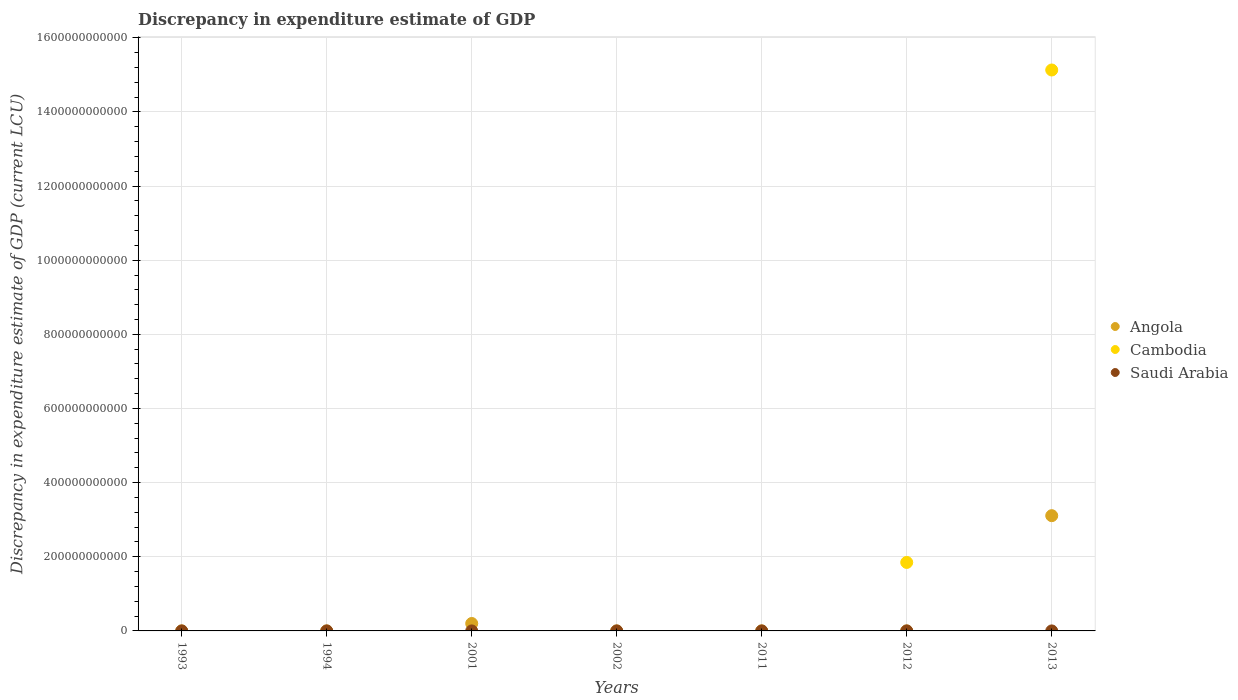What is the discrepancy in expenditure estimate of GDP in Saudi Arabia in 2012?
Provide a succinct answer. 0. Across all years, what is the maximum discrepancy in expenditure estimate of GDP in Angola?
Your answer should be compact. 3.11e+11. What is the total discrepancy in expenditure estimate of GDP in Angola in the graph?
Make the answer very short. 3.31e+11. What is the difference between the discrepancy in expenditure estimate of GDP in Saudi Arabia in 1994 and that in 2013?
Provide a short and direct response. 1.00e+06. What is the difference between the discrepancy in expenditure estimate of GDP in Angola in 2011 and the discrepancy in expenditure estimate of GDP in Saudi Arabia in 2001?
Keep it short and to the point. -1.00e+06. What is the average discrepancy in expenditure estimate of GDP in Cambodia per year?
Your answer should be very brief. 2.43e+11. In the year 2013, what is the difference between the discrepancy in expenditure estimate of GDP in Cambodia and discrepancy in expenditure estimate of GDP in Saudi Arabia?
Your answer should be compact. 1.51e+12. What is the ratio of the discrepancy in expenditure estimate of GDP in Angola in 2002 to that in 2011?
Your response must be concise. 4.00e+08. What is the difference between the highest and the second highest discrepancy in expenditure estimate of GDP in Angola?
Offer a very short reply. 2.91e+11. What is the difference between the highest and the lowest discrepancy in expenditure estimate of GDP in Cambodia?
Your answer should be compact. 1.51e+12. Is the sum of the discrepancy in expenditure estimate of GDP in Angola in 1993 and 1994 greater than the maximum discrepancy in expenditure estimate of GDP in Cambodia across all years?
Your answer should be compact. No. Does the discrepancy in expenditure estimate of GDP in Saudi Arabia monotonically increase over the years?
Ensure brevity in your answer.  No. How many dotlines are there?
Provide a short and direct response. 3. How many years are there in the graph?
Your answer should be very brief. 7. What is the difference between two consecutive major ticks on the Y-axis?
Offer a very short reply. 2.00e+11. Are the values on the major ticks of Y-axis written in scientific E-notation?
Your response must be concise. No. Does the graph contain any zero values?
Offer a terse response. Yes. What is the title of the graph?
Ensure brevity in your answer.  Discrepancy in expenditure estimate of GDP. Does "Jamaica" appear as one of the legend labels in the graph?
Provide a succinct answer. No. What is the label or title of the Y-axis?
Provide a succinct answer. Discrepancy in expenditure estimate of GDP (current LCU). What is the Discrepancy in expenditure estimate of GDP (current LCU) of Angola in 1993?
Offer a terse response. 4100. What is the Discrepancy in expenditure estimate of GDP (current LCU) in Angola in 1994?
Make the answer very short. 4.03e+04. What is the Discrepancy in expenditure estimate of GDP (current LCU) in Saudi Arabia in 1994?
Keep it short and to the point. 1.00e+06. What is the Discrepancy in expenditure estimate of GDP (current LCU) of Angola in 2001?
Provide a short and direct response. 2.00e+1. What is the Discrepancy in expenditure estimate of GDP (current LCU) in Saudi Arabia in 2001?
Provide a succinct answer. 1.00e+06. What is the Discrepancy in expenditure estimate of GDP (current LCU) in Cambodia in 2002?
Ensure brevity in your answer.  0. What is the Discrepancy in expenditure estimate of GDP (current LCU) of Angola in 2011?
Offer a very short reply. 0. What is the Discrepancy in expenditure estimate of GDP (current LCU) in Cambodia in 2011?
Your answer should be very brief. 0. What is the Discrepancy in expenditure estimate of GDP (current LCU) in Angola in 2012?
Offer a terse response. 0. What is the Discrepancy in expenditure estimate of GDP (current LCU) of Cambodia in 2012?
Your answer should be compact. 1.85e+11. What is the Discrepancy in expenditure estimate of GDP (current LCU) in Angola in 2013?
Give a very brief answer. 3.11e+11. What is the Discrepancy in expenditure estimate of GDP (current LCU) in Cambodia in 2013?
Provide a succinct answer. 1.51e+12. What is the Discrepancy in expenditure estimate of GDP (current LCU) in Saudi Arabia in 2013?
Offer a very short reply. 0. Across all years, what is the maximum Discrepancy in expenditure estimate of GDP (current LCU) of Angola?
Provide a succinct answer. 3.11e+11. Across all years, what is the maximum Discrepancy in expenditure estimate of GDP (current LCU) of Cambodia?
Give a very brief answer. 1.51e+12. Across all years, what is the maximum Discrepancy in expenditure estimate of GDP (current LCU) in Saudi Arabia?
Your response must be concise. 1.00e+06. What is the total Discrepancy in expenditure estimate of GDP (current LCU) of Angola in the graph?
Offer a terse response. 3.31e+11. What is the total Discrepancy in expenditure estimate of GDP (current LCU) in Cambodia in the graph?
Your response must be concise. 1.70e+12. What is the total Discrepancy in expenditure estimate of GDP (current LCU) of Saudi Arabia in the graph?
Provide a short and direct response. 2.00e+06. What is the difference between the Discrepancy in expenditure estimate of GDP (current LCU) of Angola in 1993 and that in 1994?
Your answer should be compact. -3.62e+04. What is the difference between the Discrepancy in expenditure estimate of GDP (current LCU) in Angola in 1993 and that in 2001?
Provide a succinct answer. -2.00e+1. What is the difference between the Discrepancy in expenditure estimate of GDP (current LCU) in Angola in 1993 and that in 2002?
Provide a short and direct response. -9.96e+05. What is the difference between the Discrepancy in expenditure estimate of GDP (current LCU) in Angola in 1993 and that in 2011?
Your answer should be compact. 4100. What is the difference between the Discrepancy in expenditure estimate of GDP (current LCU) of Angola in 1993 and that in 2013?
Offer a very short reply. -3.11e+11. What is the difference between the Discrepancy in expenditure estimate of GDP (current LCU) of Angola in 1994 and that in 2001?
Offer a terse response. -2.00e+1. What is the difference between the Discrepancy in expenditure estimate of GDP (current LCU) in Angola in 1994 and that in 2002?
Offer a very short reply. -9.60e+05. What is the difference between the Discrepancy in expenditure estimate of GDP (current LCU) in Angola in 1994 and that in 2011?
Your answer should be very brief. 4.03e+04. What is the difference between the Discrepancy in expenditure estimate of GDP (current LCU) in Angola in 1994 and that in 2013?
Make the answer very short. -3.11e+11. What is the difference between the Discrepancy in expenditure estimate of GDP (current LCU) in Saudi Arabia in 1994 and that in 2013?
Your answer should be very brief. 1.00e+06. What is the difference between the Discrepancy in expenditure estimate of GDP (current LCU) of Angola in 2001 and that in 2002?
Ensure brevity in your answer.  2.00e+1. What is the difference between the Discrepancy in expenditure estimate of GDP (current LCU) in Angola in 2001 and that in 2011?
Provide a succinct answer. 2.00e+1. What is the difference between the Discrepancy in expenditure estimate of GDP (current LCU) in Angola in 2001 and that in 2013?
Offer a terse response. -2.91e+11. What is the difference between the Discrepancy in expenditure estimate of GDP (current LCU) in Saudi Arabia in 2001 and that in 2013?
Give a very brief answer. 1.00e+06. What is the difference between the Discrepancy in expenditure estimate of GDP (current LCU) of Angola in 2002 and that in 2011?
Your answer should be compact. 1.00e+06. What is the difference between the Discrepancy in expenditure estimate of GDP (current LCU) in Angola in 2002 and that in 2013?
Your answer should be very brief. -3.11e+11. What is the difference between the Discrepancy in expenditure estimate of GDP (current LCU) in Angola in 2011 and that in 2013?
Your answer should be compact. -3.11e+11. What is the difference between the Discrepancy in expenditure estimate of GDP (current LCU) of Cambodia in 2012 and that in 2013?
Your response must be concise. -1.33e+12. What is the difference between the Discrepancy in expenditure estimate of GDP (current LCU) in Angola in 1993 and the Discrepancy in expenditure estimate of GDP (current LCU) in Saudi Arabia in 1994?
Your response must be concise. -9.96e+05. What is the difference between the Discrepancy in expenditure estimate of GDP (current LCU) in Angola in 1993 and the Discrepancy in expenditure estimate of GDP (current LCU) in Saudi Arabia in 2001?
Offer a very short reply. -9.96e+05. What is the difference between the Discrepancy in expenditure estimate of GDP (current LCU) in Angola in 1993 and the Discrepancy in expenditure estimate of GDP (current LCU) in Cambodia in 2012?
Provide a succinct answer. -1.85e+11. What is the difference between the Discrepancy in expenditure estimate of GDP (current LCU) of Angola in 1993 and the Discrepancy in expenditure estimate of GDP (current LCU) of Cambodia in 2013?
Your answer should be very brief. -1.51e+12. What is the difference between the Discrepancy in expenditure estimate of GDP (current LCU) of Angola in 1993 and the Discrepancy in expenditure estimate of GDP (current LCU) of Saudi Arabia in 2013?
Make the answer very short. 4100. What is the difference between the Discrepancy in expenditure estimate of GDP (current LCU) in Angola in 1994 and the Discrepancy in expenditure estimate of GDP (current LCU) in Saudi Arabia in 2001?
Ensure brevity in your answer.  -9.60e+05. What is the difference between the Discrepancy in expenditure estimate of GDP (current LCU) in Angola in 1994 and the Discrepancy in expenditure estimate of GDP (current LCU) in Cambodia in 2012?
Your answer should be very brief. -1.85e+11. What is the difference between the Discrepancy in expenditure estimate of GDP (current LCU) in Angola in 1994 and the Discrepancy in expenditure estimate of GDP (current LCU) in Cambodia in 2013?
Provide a succinct answer. -1.51e+12. What is the difference between the Discrepancy in expenditure estimate of GDP (current LCU) in Angola in 1994 and the Discrepancy in expenditure estimate of GDP (current LCU) in Saudi Arabia in 2013?
Give a very brief answer. 4.03e+04. What is the difference between the Discrepancy in expenditure estimate of GDP (current LCU) in Angola in 2001 and the Discrepancy in expenditure estimate of GDP (current LCU) in Cambodia in 2012?
Provide a succinct answer. -1.65e+11. What is the difference between the Discrepancy in expenditure estimate of GDP (current LCU) in Angola in 2001 and the Discrepancy in expenditure estimate of GDP (current LCU) in Cambodia in 2013?
Provide a short and direct response. -1.49e+12. What is the difference between the Discrepancy in expenditure estimate of GDP (current LCU) of Angola in 2001 and the Discrepancy in expenditure estimate of GDP (current LCU) of Saudi Arabia in 2013?
Offer a terse response. 2.00e+1. What is the difference between the Discrepancy in expenditure estimate of GDP (current LCU) of Angola in 2002 and the Discrepancy in expenditure estimate of GDP (current LCU) of Cambodia in 2012?
Keep it short and to the point. -1.85e+11. What is the difference between the Discrepancy in expenditure estimate of GDP (current LCU) in Angola in 2002 and the Discrepancy in expenditure estimate of GDP (current LCU) in Cambodia in 2013?
Your answer should be compact. -1.51e+12. What is the difference between the Discrepancy in expenditure estimate of GDP (current LCU) of Angola in 2002 and the Discrepancy in expenditure estimate of GDP (current LCU) of Saudi Arabia in 2013?
Your answer should be compact. 1.00e+06. What is the difference between the Discrepancy in expenditure estimate of GDP (current LCU) of Angola in 2011 and the Discrepancy in expenditure estimate of GDP (current LCU) of Cambodia in 2012?
Offer a very short reply. -1.85e+11. What is the difference between the Discrepancy in expenditure estimate of GDP (current LCU) of Angola in 2011 and the Discrepancy in expenditure estimate of GDP (current LCU) of Cambodia in 2013?
Your response must be concise. -1.51e+12. What is the difference between the Discrepancy in expenditure estimate of GDP (current LCU) in Angola in 2011 and the Discrepancy in expenditure estimate of GDP (current LCU) in Saudi Arabia in 2013?
Your answer should be very brief. 0. What is the difference between the Discrepancy in expenditure estimate of GDP (current LCU) of Cambodia in 2012 and the Discrepancy in expenditure estimate of GDP (current LCU) of Saudi Arabia in 2013?
Give a very brief answer. 1.85e+11. What is the average Discrepancy in expenditure estimate of GDP (current LCU) of Angola per year?
Offer a terse response. 4.73e+1. What is the average Discrepancy in expenditure estimate of GDP (current LCU) of Cambodia per year?
Keep it short and to the point. 2.43e+11. What is the average Discrepancy in expenditure estimate of GDP (current LCU) in Saudi Arabia per year?
Offer a very short reply. 2.86e+05. In the year 1994, what is the difference between the Discrepancy in expenditure estimate of GDP (current LCU) in Angola and Discrepancy in expenditure estimate of GDP (current LCU) in Saudi Arabia?
Ensure brevity in your answer.  -9.60e+05. In the year 2001, what is the difference between the Discrepancy in expenditure estimate of GDP (current LCU) in Angola and Discrepancy in expenditure estimate of GDP (current LCU) in Saudi Arabia?
Provide a succinct answer. 2.00e+1. In the year 2013, what is the difference between the Discrepancy in expenditure estimate of GDP (current LCU) in Angola and Discrepancy in expenditure estimate of GDP (current LCU) in Cambodia?
Offer a terse response. -1.20e+12. In the year 2013, what is the difference between the Discrepancy in expenditure estimate of GDP (current LCU) of Angola and Discrepancy in expenditure estimate of GDP (current LCU) of Saudi Arabia?
Make the answer very short. 3.11e+11. In the year 2013, what is the difference between the Discrepancy in expenditure estimate of GDP (current LCU) in Cambodia and Discrepancy in expenditure estimate of GDP (current LCU) in Saudi Arabia?
Provide a short and direct response. 1.51e+12. What is the ratio of the Discrepancy in expenditure estimate of GDP (current LCU) in Angola in 1993 to that in 1994?
Give a very brief answer. 0.1. What is the ratio of the Discrepancy in expenditure estimate of GDP (current LCU) in Angola in 1993 to that in 2002?
Make the answer very short. 0. What is the ratio of the Discrepancy in expenditure estimate of GDP (current LCU) of Angola in 1993 to that in 2011?
Offer a terse response. 1.64e+06. What is the ratio of the Discrepancy in expenditure estimate of GDP (current LCU) of Angola in 1994 to that in 2002?
Give a very brief answer. 0.04. What is the ratio of the Discrepancy in expenditure estimate of GDP (current LCU) of Angola in 1994 to that in 2011?
Offer a terse response. 1.61e+07. What is the ratio of the Discrepancy in expenditure estimate of GDP (current LCU) in Saudi Arabia in 1994 to that in 2013?
Provide a succinct answer. 8.33e+09. What is the ratio of the Discrepancy in expenditure estimate of GDP (current LCU) in Angola in 2001 to that in 2002?
Give a very brief answer. 2.00e+04. What is the ratio of the Discrepancy in expenditure estimate of GDP (current LCU) in Angola in 2001 to that in 2011?
Your answer should be very brief. 8.01e+12. What is the ratio of the Discrepancy in expenditure estimate of GDP (current LCU) in Angola in 2001 to that in 2013?
Your response must be concise. 0.06. What is the ratio of the Discrepancy in expenditure estimate of GDP (current LCU) of Saudi Arabia in 2001 to that in 2013?
Offer a very short reply. 8.33e+09. What is the ratio of the Discrepancy in expenditure estimate of GDP (current LCU) in Angola in 2002 to that in 2011?
Your answer should be very brief. 4.00e+08. What is the ratio of the Discrepancy in expenditure estimate of GDP (current LCU) of Angola in 2002 to that in 2013?
Provide a short and direct response. 0. What is the ratio of the Discrepancy in expenditure estimate of GDP (current LCU) in Cambodia in 2012 to that in 2013?
Give a very brief answer. 0.12. What is the difference between the highest and the second highest Discrepancy in expenditure estimate of GDP (current LCU) of Angola?
Your answer should be very brief. 2.91e+11. What is the difference between the highest and the second highest Discrepancy in expenditure estimate of GDP (current LCU) in Saudi Arabia?
Keep it short and to the point. 0. What is the difference between the highest and the lowest Discrepancy in expenditure estimate of GDP (current LCU) in Angola?
Make the answer very short. 3.11e+11. What is the difference between the highest and the lowest Discrepancy in expenditure estimate of GDP (current LCU) in Cambodia?
Make the answer very short. 1.51e+12. 